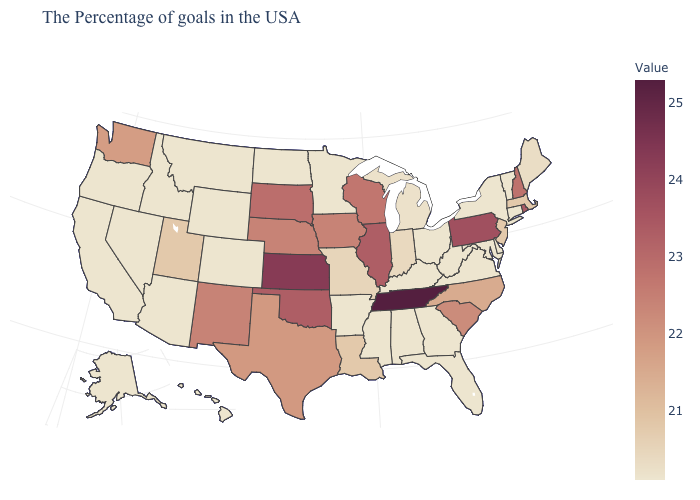Is the legend a continuous bar?
Give a very brief answer. Yes. Which states have the lowest value in the South?
Write a very short answer. Delaware, Maryland, Virginia, West Virginia, Florida, Georgia, Kentucky, Alabama, Mississippi, Arkansas. Among the states that border Mississippi , does Alabama have the highest value?
Give a very brief answer. No. Among the states that border Michigan , does Wisconsin have the lowest value?
Keep it brief. No. Among the states that border New Hampshire , which have the lowest value?
Write a very short answer. Vermont. 